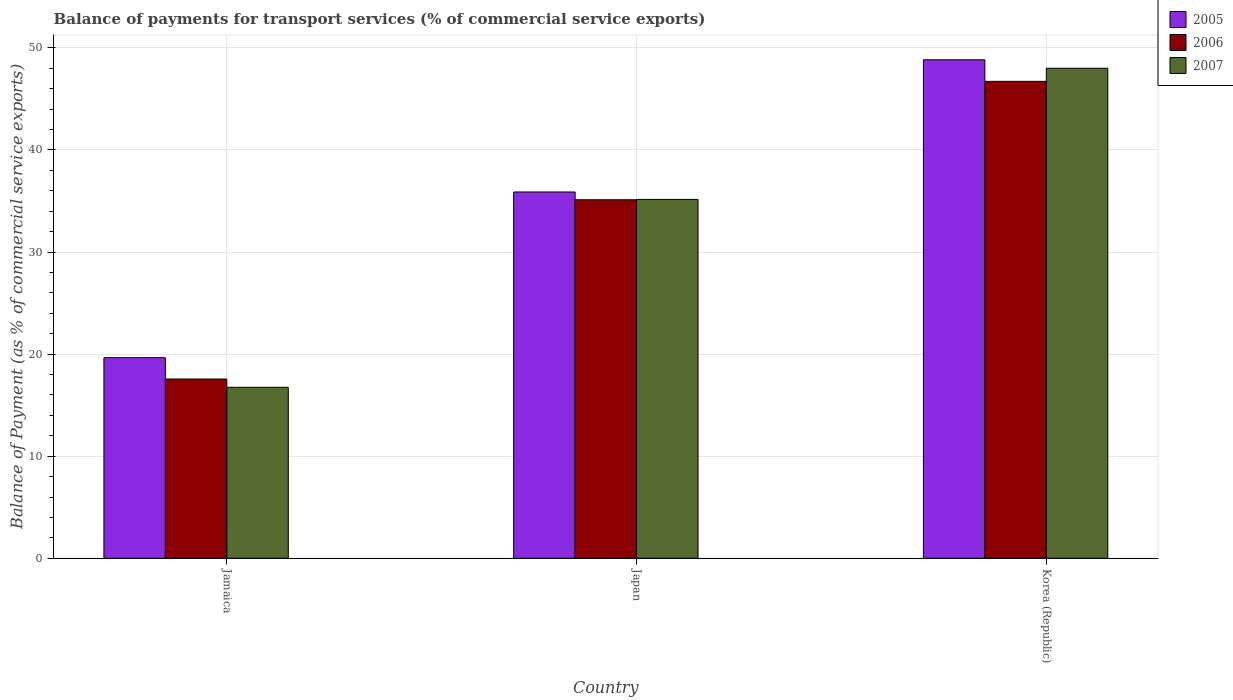How many different coloured bars are there?
Keep it short and to the point. 3. How many groups of bars are there?
Ensure brevity in your answer.  3. Are the number of bars on each tick of the X-axis equal?
Give a very brief answer. Yes. How many bars are there on the 2nd tick from the left?
Keep it short and to the point. 3. What is the label of the 1st group of bars from the left?
Ensure brevity in your answer.  Jamaica. What is the balance of payments for transport services in 2006 in Jamaica?
Make the answer very short. 17.56. Across all countries, what is the maximum balance of payments for transport services in 2006?
Give a very brief answer. 46.72. Across all countries, what is the minimum balance of payments for transport services in 2006?
Keep it short and to the point. 17.56. In which country was the balance of payments for transport services in 2006 minimum?
Ensure brevity in your answer.  Jamaica. What is the total balance of payments for transport services in 2006 in the graph?
Offer a very short reply. 99.41. What is the difference between the balance of payments for transport services in 2006 in Jamaica and that in Japan?
Make the answer very short. -17.56. What is the difference between the balance of payments for transport services in 2007 in Japan and the balance of payments for transport services in 2005 in Korea (Republic)?
Provide a succinct answer. -13.68. What is the average balance of payments for transport services in 2005 per country?
Your answer should be compact. 34.79. What is the difference between the balance of payments for transport services of/in 2006 and balance of payments for transport services of/in 2007 in Korea (Republic)?
Give a very brief answer. -1.29. In how many countries, is the balance of payments for transport services in 2007 greater than 26 %?
Provide a succinct answer. 2. What is the ratio of the balance of payments for transport services in 2005 in Jamaica to that in Korea (Republic)?
Provide a short and direct response. 0.4. Is the balance of payments for transport services in 2007 in Jamaica less than that in Japan?
Provide a short and direct response. Yes. Is the difference between the balance of payments for transport services in 2006 in Jamaica and Japan greater than the difference between the balance of payments for transport services in 2007 in Jamaica and Japan?
Make the answer very short. Yes. What is the difference between the highest and the second highest balance of payments for transport services in 2006?
Make the answer very short. -17.56. What is the difference between the highest and the lowest balance of payments for transport services in 2005?
Your answer should be very brief. 29.19. In how many countries, is the balance of payments for transport services in 2006 greater than the average balance of payments for transport services in 2006 taken over all countries?
Offer a very short reply. 2. What does the 3rd bar from the right in Jamaica represents?
Make the answer very short. 2005. Are all the bars in the graph horizontal?
Ensure brevity in your answer.  No. What is the difference between two consecutive major ticks on the Y-axis?
Offer a very short reply. 10. Does the graph contain any zero values?
Your answer should be very brief. No. Does the graph contain grids?
Give a very brief answer. Yes. Where does the legend appear in the graph?
Your response must be concise. Top right. How are the legend labels stacked?
Offer a terse response. Vertical. What is the title of the graph?
Make the answer very short. Balance of payments for transport services (% of commercial service exports). What is the label or title of the X-axis?
Offer a terse response. Country. What is the label or title of the Y-axis?
Your answer should be very brief. Balance of Payment (as % of commercial service exports). What is the Balance of Payment (as % of commercial service exports) in 2005 in Jamaica?
Your answer should be very brief. 19.65. What is the Balance of Payment (as % of commercial service exports) in 2006 in Jamaica?
Keep it short and to the point. 17.56. What is the Balance of Payment (as % of commercial service exports) in 2007 in Jamaica?
Offer a terse response. 16.75. What is the Balance of Payment (as % of commercial service exports) of 2005 in Japan?
Give a very brief answer. 35.89. What is the Balance of Payment (as % of commercial service exports) in 2006 in Japan?
Provide a short and direct response. 35.12. What is the Balance of Payment (as % of commercial service exports) in 2007 in Japan?
Provide a succinct answer. 35.16. What is the Balance of Payment (as % of commercial service exports) of 2005 in Korea (Republic)?
Your answer should be very brief. 48.84. What is the Balance of Payment (as % of commercial service exports) of 2006 in Korea (Republic)?
Your answer should be compact. 46.72. What is the Balance of Payment (as % of commercial service exports) in 2007 in Korea (Republic)?
Provide a succinct answer. 48.01. Across all countries, what is the maximum Balance of Payment (as % of commercial service exports) of 2005?
Ensure brevity in your answer.  48.84. Across all countries, what is the maximum Balance of Payment (as % of commercial service exports) of 2006?
Make the answer very short. 46.72. Across all countries, what is the maximum Balance of Payment (as % of commercial service exports) of 2007?
Provide a succinct answer. 48.01. Across all countries, what is the minimum Balance of Payment (as % of commercial service exports) of 2005?
Keep it short and to the point. 19.65. Across all countries, what is the minimum Balance of Payment (as % of commercial service exports) of 2006?
Keep it short and to the point. 17.56. Across all countries, what is the minimum Balance of Payment (as % of commercial service exports) of 2007?
Make the answer very short. 16.75. What is the total Balance of Payment (as % of commercial service exports) of 2005 in the graph?
Make the answer very short. 104.37. What is the total Balance of Payment (as % of commercial service exports) of 2006 in the graph?
Your response must be concise. 99.41. What is the total Balance of Payment (as % of commercial service exports) in 2007 in the graph?
Provide a succinct answer. 99.92. What is the difference between the Balance of Payment (as % of commercial service exports) in 2005 in Jamaica and that in Japan?
Your response must be concise. -16.24. What is the difference between the Balance of Payment (as % of commercial service exports) in 2006 in Jamaica and that in Japan?
Your answer should be compact. -17.56. What is the difference between the Balance of Payment (as % of commercial service exports) in 2007 in Jamaica and that in Japan?
Provide a short and direct response. -18.41. What is the difference between the Balance of Payment (as % of commercial service exports) in 2005 in Jamaica and that in Korea (Republic)?
Provide a short and direct response. -29.19. What is the difference between the Balance of Payment (as % of commercial service exports) in 2006 in Jamaica and that in Korea (Republic)?
Offer a terse response. -29.16. What is the difference between the Balance of Payment (as % of commercial service exports) in 2007 in Jamaica and that in Korea (Republic)?
Give a very brief answer. -31.26. What is the difference between the Balance of Payment (as % of commercial service exports) in 2005 in Japan and that in Korea (Republic)?
Your response must be concise. -12.95. What is the difference between the Balance of Payment (as % of commercial service exports) in 2006 in Japan and that in Korea (Republic)?
Offer a very short reply. -11.6. What is the difference between the Balance of Payment (as % of commercial service exports) of 2007 in Japan and that in Korea (Republic)?
Ensure brevity in your answer.  -12.85. What is the difference between the Balance of Payment (as % of commercial service exports) of 2005 in Jamaica and the Balance of Payment (as % of commercial service exports) of 2006 in Japan?
Your answer should be compact. -15.47. What is the difference between the Balance of Payment (as % of commercial service exports) in 2005 in Jamaica and the Balance of Payment (as % of commercial service exports) in 2007 in Japan?
Give a very brief answer. -15.51. What is the difference between the Balance of Payment (as % of commercial service exports) of 2006 in Jamaica and the Balance of Payment (as % of commercial service exports) of 2007 in Japan?
Your answer should be compact. -17.6. What is the difference between the Balance of Payment (as % of commercial service exports) in 2005 in Jamaica and the Balance of Payment (as % of commercial service exports) in 2006 in Korea (Republic)?
Offer a very short reply. -27.07. What is the difference between the Balance of Payment (as % of commercial service exports) of 2005 in Jamaica and the Balance of Payment (as % of commercial service exports) of 2007 in Korea (Republic)?
Your response must be concise. -28.36. What is the difference between the Balance of Payment (as % of commercial service exports) in 2006 in Jamaica and the Balance of Payment (as % of commercial service exports) in 2007 in Korea (Republic)?
Give a very brief answer. -30.45. What is the difference between the Balance of Payment (as % of commercial service exports) in 2005 in Japan and the Balance of Payment (as % of commercial service exports) in 2006 in Korea (Republic)?
Your answer should be compact. -10.84. What is the difference between the Balance of Payment (as % of commercial service exports) of 2005 in Japan and the Balance of Payment (as % of commercial service exports) of 2007 in Korea (Republic)?
Provide a succinct answer. -12.12. What is the difference between the Balance of Payment (as % of commercial service exports) in 2006 in Japan and the Balance of Payment (as % of commercial service exports) in 2007 in Korea (Republic)?
Your answer should be very brief. -12.89. What is the average Balance of Payment (as % of commercial service exports) of 2005 per country?
Make the answer very short. 34.79. What is the average Balance of Payment (as % of commercial service exports) in 2006 per country?
Provide a short and direct response. 33.14. What is the average Balance of Payment (as % of commercial service exports) in 2007 per country?
Ensure brevity in your answer.  33.31. What is the difference between the Balance of Payment (as % of commercial service exports) in 2005 and Balance of Payment (as % of commercial service exports) in 2006 in Jamaica?
Provide a short and direct response. 2.09. What is the difference between the Balance of Payment (as % of commercial service exports) of 2005 and Balance of Payment (as % of commercial service exports) of 2007 in Jamaica?
Ensure brevity in your answer.  2.9. What is the difference between the Balance of Payment (as % of commercial service exports) in 2006 and Balance of Payment (as % of commercial service exports) in 2007 in Jamaica?
Offer a very short reply. 0.81. What is the difference between the Balance of Payment (as % of commercial service exports) of 2005 and Balance of Payment (as % of commercial service exports) of 2006 in Japan?
Your answer should be compact. 0.76. What is the difference between the Balance of Payment (as % of commercial service exports) in 2005 and Balance of Payment (as % of commercial service exports) in 2007 in Japan?
Give a very brief answer. 0.73. What is the difference between the Balance of Payment (as % of commercial service exports) in 2006 and Balance of Payment (as % of commercial service exports) in 2007 in Japan?
Your response must be concise. -0.03. What is the difference between the Balance of Payment (as % of commercial service exports) in 2005 and Balance of Payment (as % of commercial service exports) in 2006 in Korea (Republic)?
Your answer should be compact. 2.11. What is the difference between the Balance of Payment (as % of commercial service exports) of 2005 and Balance of Payment (as % of commercial service exports) of 2007 in Korea (Republic)?
Offer a terse response. 0.83. What is the difference between the Balance of Payment (as % of commercial service exports) in 2006 and Balance of Payment (as % of commercial service exports) in 2007 in Korea (Republic)?
Give a very brief answer. -1.29. What is the ratio of the Balance of Payment (as % of commercial service exports) in 2005 in Jamaica to that in Japan?
Your answer should be very brief. 0.55. What is the ratio of the Balance of Payment (as % of commercial service exports) of 2006 in Jamaica to that in Japan?
Make the answer very short. 0.5. What is the ratio of the Balance of Payment (as % of commercial service exports) of 2007 in Jamaica to that in Japan?
Offer a very short reply. 0.48. What is the ratio of the Balance of Payment (as % of commercial service exports) in 2005 in Jamaica to that in Korea (Republic)?
Your answer should be very brief. 0.4. What is the ratio of the Balance of Payment (as % of commercial service exports) of 2006 in Jamaica to that in Korea (Republic)?
Ensure brevity in your answer.  0.38. What is the ratio of the Balance of Payment (as % of commercial service exports) in 2007 in Jamaica to that in Korea (Republic)?
Provide a short and direct response. 0.35. What is the ratio of the Balance of Payment (as % of commercial service exports) in 2005 in Japan to that in Korea (Republic)?
Ensure brevity in your answer.  0.73. What is the ratio of the Balance of Payment (as % of commercial service exports) of 2006 in Japan to that in Korea (Republic)?
Make the answer very short. 0.75. What is the ratio of the Balance of Payment (as % of commercial service exports) in 2007 in Japan to that in Korea (Republic)?
Offer a very short reply. 0.73. What is the difference between the highest and the second highest Balance of Payment (as % of commercial service exports) in 2005?
Offer a terse response. 12.95. What is the difference between the highest and the second highest Balance of Payment (as % of commercial service exports) in 2006?
Offer a very short reply. 11.6. What is the difference between the highest and the second highest Balance of Payment (as % of commercial service exports) of 2007?
Keep it short and to the point. 12.85. What is the difference between the highest and the lowest Balance of Payment (as % of commercial service exports) of 2005?
Your answer should be compact. 29.19. What is the difference between the highest and the lowest Balance of Payment (as % of commercial service exports) in 2006?
Provide a succinct answer. 29.16. What is the difference between the highest and the lowest Balance of Payment (as % of commercial service exports) in 2007?
Your response must be concise. 31.26. 